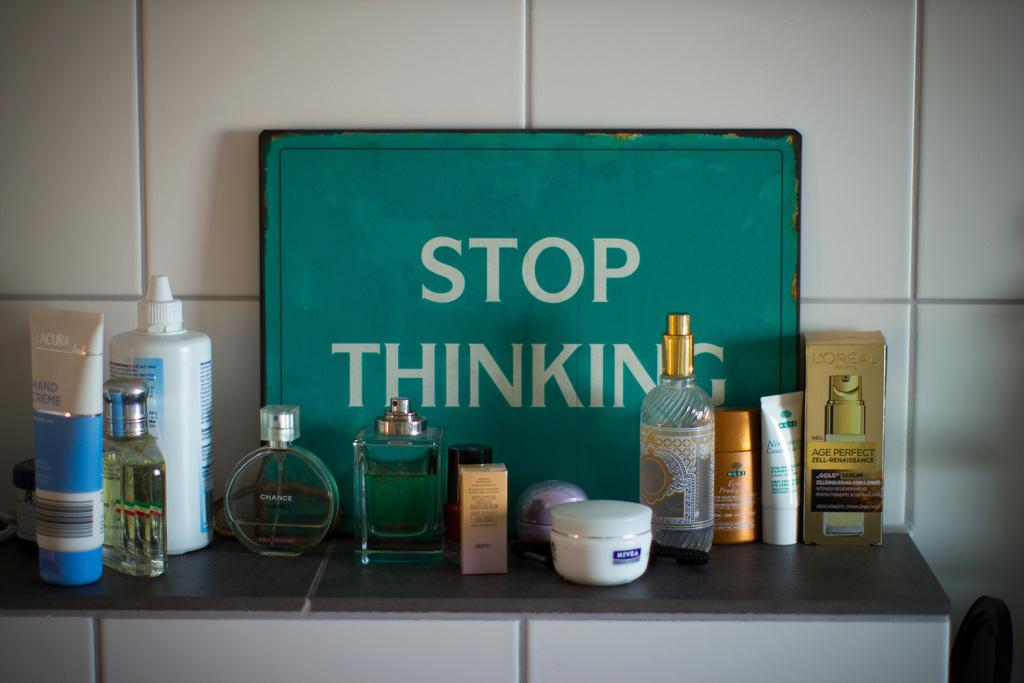<image>
Create a compact narrative representing the image presented. Bottles on a table in front of a sign that says STOP THINKING. 